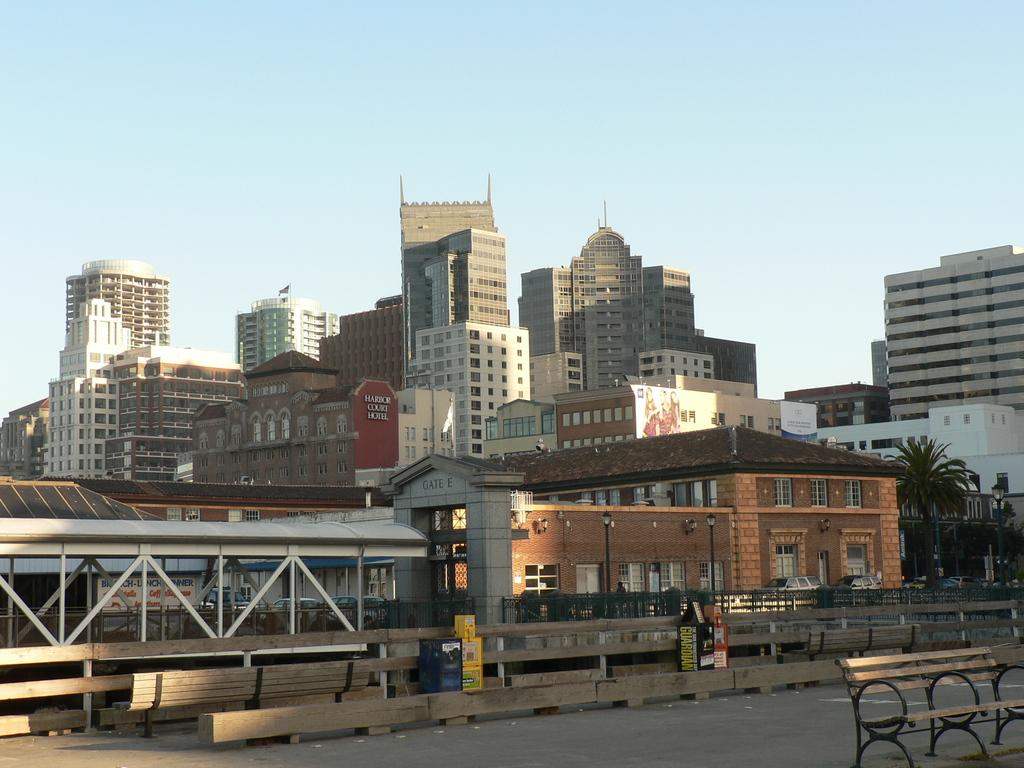What type of structures can be seen in the image? There are buildings in the image. What else is present in the image besides the buildings? There is a road in the image. Can you see any goldfish swimming in the image? There are no goldfish present in the image. Where might the children be during their recess in the image? There is no reference to children or a recess in the image. Is there a porter present in the image to assist with luggage? There is no indication of a porter or luggage in the image. 